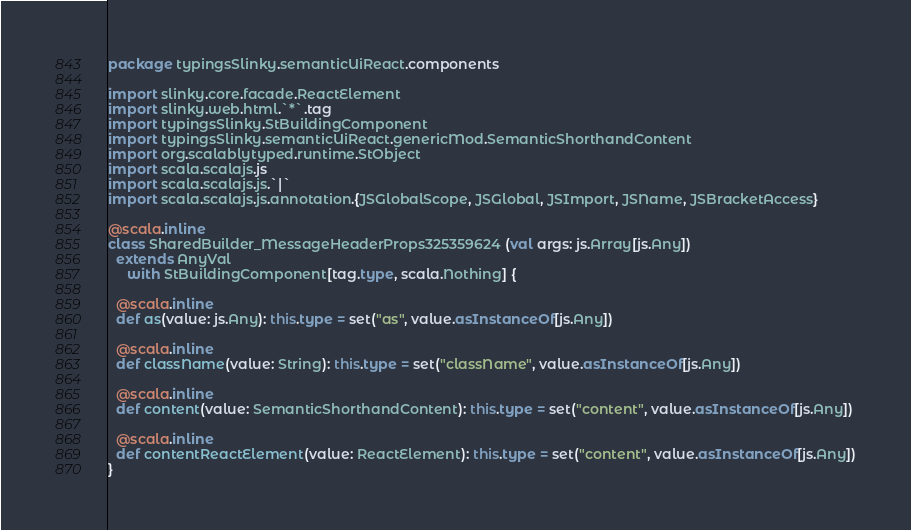<code> <loc_0><loc_0><loc_500><loc_500><_Scala_>package typingsSlinky.semanticUiReact.components

import slinky.core.facade.ReactElement
import slinky.web.html.`*`.tag
import typingsSlinky.StBuildingComponent
import typingsSlinky.semanticUiReact.genericMod.SemanticShorthandContent
import org.scalablytyped.runtime.StObject
import scala.scalajs.js
import scala.scalajs.js.`|`
import scala.scalajs.js.annotation.{JSGlobalScope, JSGlobal, JSImport, JSName, JSBracketAccess}

@scala.inline
class SharedBuilder_MessageHeaderProps325359624 (val args: js.Array[js.Any])
  extends AnyVal
     with StBuildingComponent[tag.type, scala.Nothing] {
  
  @scala.inline
  def as(value: js.Any): this.type = set("as", value.asInstanceOf[js.Any])
  
  @scala.inline
  def className(value: String): this.type = set("className", value.asInstanceOf[js.Any])
  
  @scala.inline
  def content(value: SemanticShorthandContent): this.type = set("content", value.asInstanceOf[js.Any])
  
  @scala.inline
  def contentReactElement(value: ReactElement): this.type = set("content", value.asInstanceOf[js.Any])
}
</code> 